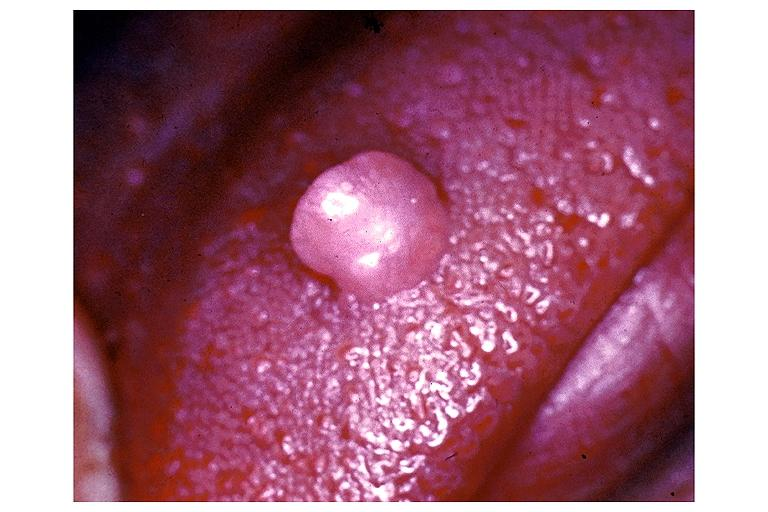s lesion in dome of uterus present?
Answer the question using a single word or phrase. No 